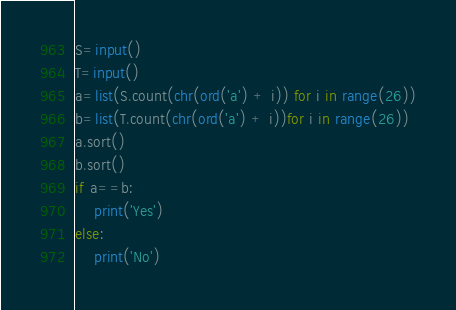<code> <loc_0><loc_0><loc_500><loc_500><_Python_>S=input()
T=input()
a=list(S.count(chr(ord('a') + i)) for i in range(26))
b=list(T.count(chr(ord('a') + i))for i in range(26))
a.sort()
b.sort()
if a==b:
    print('Yes')
else:
    print('No')</code> 